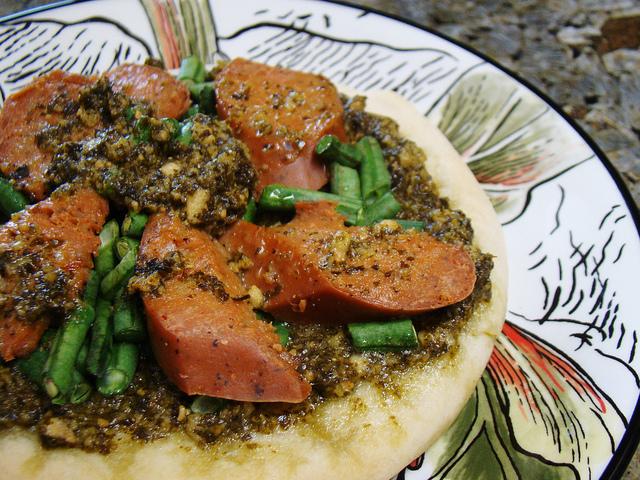What is the orange vegetable?
Write a very short answer. Sweet potato. What is the pizza sitting on?
Be succinct. Plate. What green vegetable is in the dish?
Give a very brief answer. Beans. 